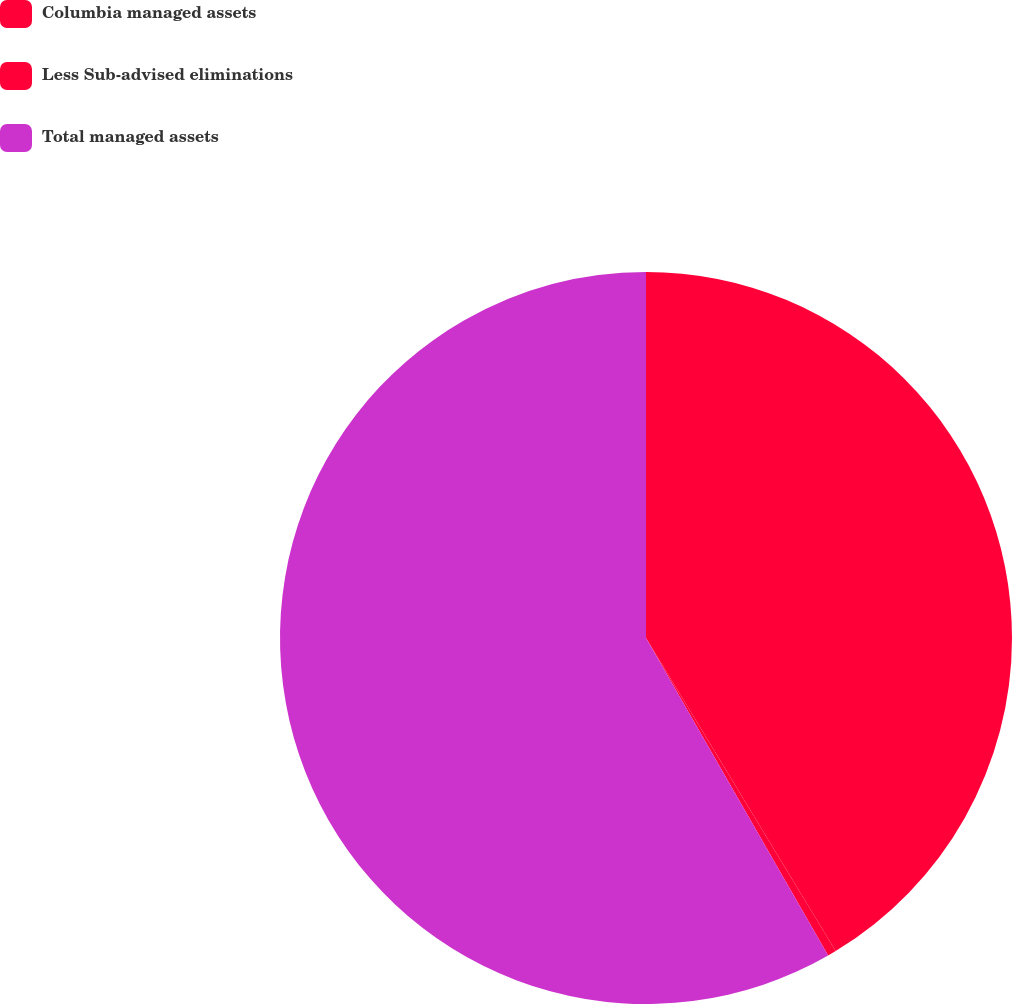Convert chart. <chart><loc_0><loc_0><loc_500><loc_500><pie_chart><fcel>Columbia managed assets<fcel>Less Sub-advised eliminations<fcel>Total managed assets<nl><fcel>41.33%<fcel>0.38%<fcel>58.29%<nl></chart> 